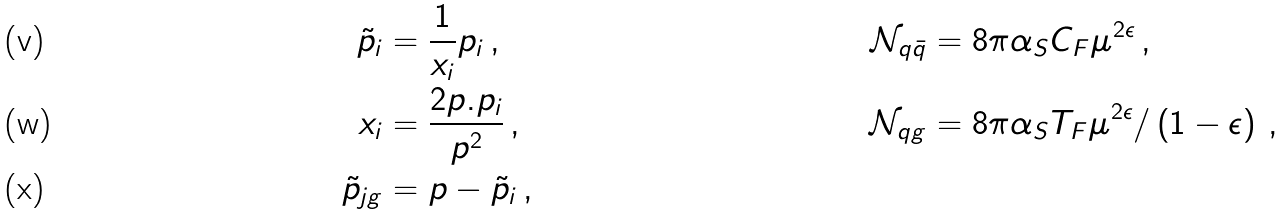<formula> <loc_0><loc_0><loc_500><loc_500>\tilde { p } _ { i } & = \frac { 1 } { x _ { i } } p _ { i } \, , & \mathcal { N } _ { q \bar { q } } & = 8 \pi \alpha _ { S } C _ { F } \mu ^ { 2 \epsilon } \, , \\ x _ { i } & = \frac { 2 p . p _ { i } } { p ^ { 2 } } \, , & \mathcal { N } _ { q g } & = 8 \pi \alpha _ { S } T _ { F } \mu ^ { 2 \epsilon } / \left ( 1 - \epsilon \right ) \, , \\ \tilde { p } _ { j g } & = p - \tilde { p } _ { i } \, ,</formula> 